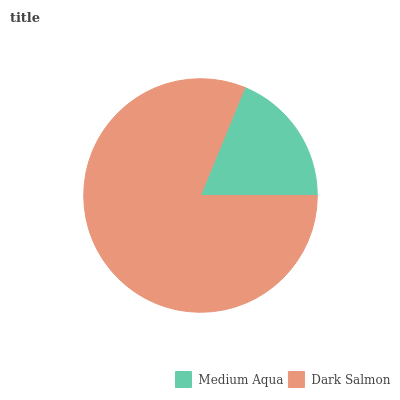Is Medium Aqua the minimum?
Answer yes or no. Yes. Is Dark Salmon the maximum?
Answer yes or no. Yes. Is Dark Salmon the minimum?
Answer yes or no. No. Is Dark Salmon greater than Medium Aqua?
Answer yes or no. Yes. Is Medium Aqua less than Dark Salmon?
Answer yes or no. Yes. Is Medium Aqua greater than Dark Salmon?
Answer yes or no. No. Is Dark Salmon less than Medium Aqua?
Answer yes or no. No. Is Dark Salmon the high median?
Answer yes or no. Yes. Is Medium Aqua the low median?
Answer yes or no. Yes. Is Medium Aqua the high median?
Answer yes or no. No. Is Dark Salmon the low median?
Answer yes or no. No. 